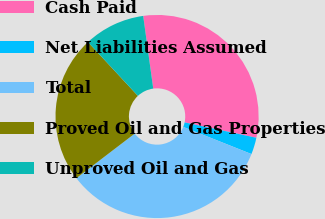Convert chart. <chart><loc_0><loc_0><loc_500><loc_500><pie_chart><fcel>Cash Paid<fcel>Net Liabilities Assumed<fcel>Total<fcel>Proved Oil and Gas Properties<fcel>Unproved Oil and Gas<nl><fcel>30.54%<fcel>2.67%<fcel>33.59%<fcel>23.47%<fcel>9.73%<nl></chart> 